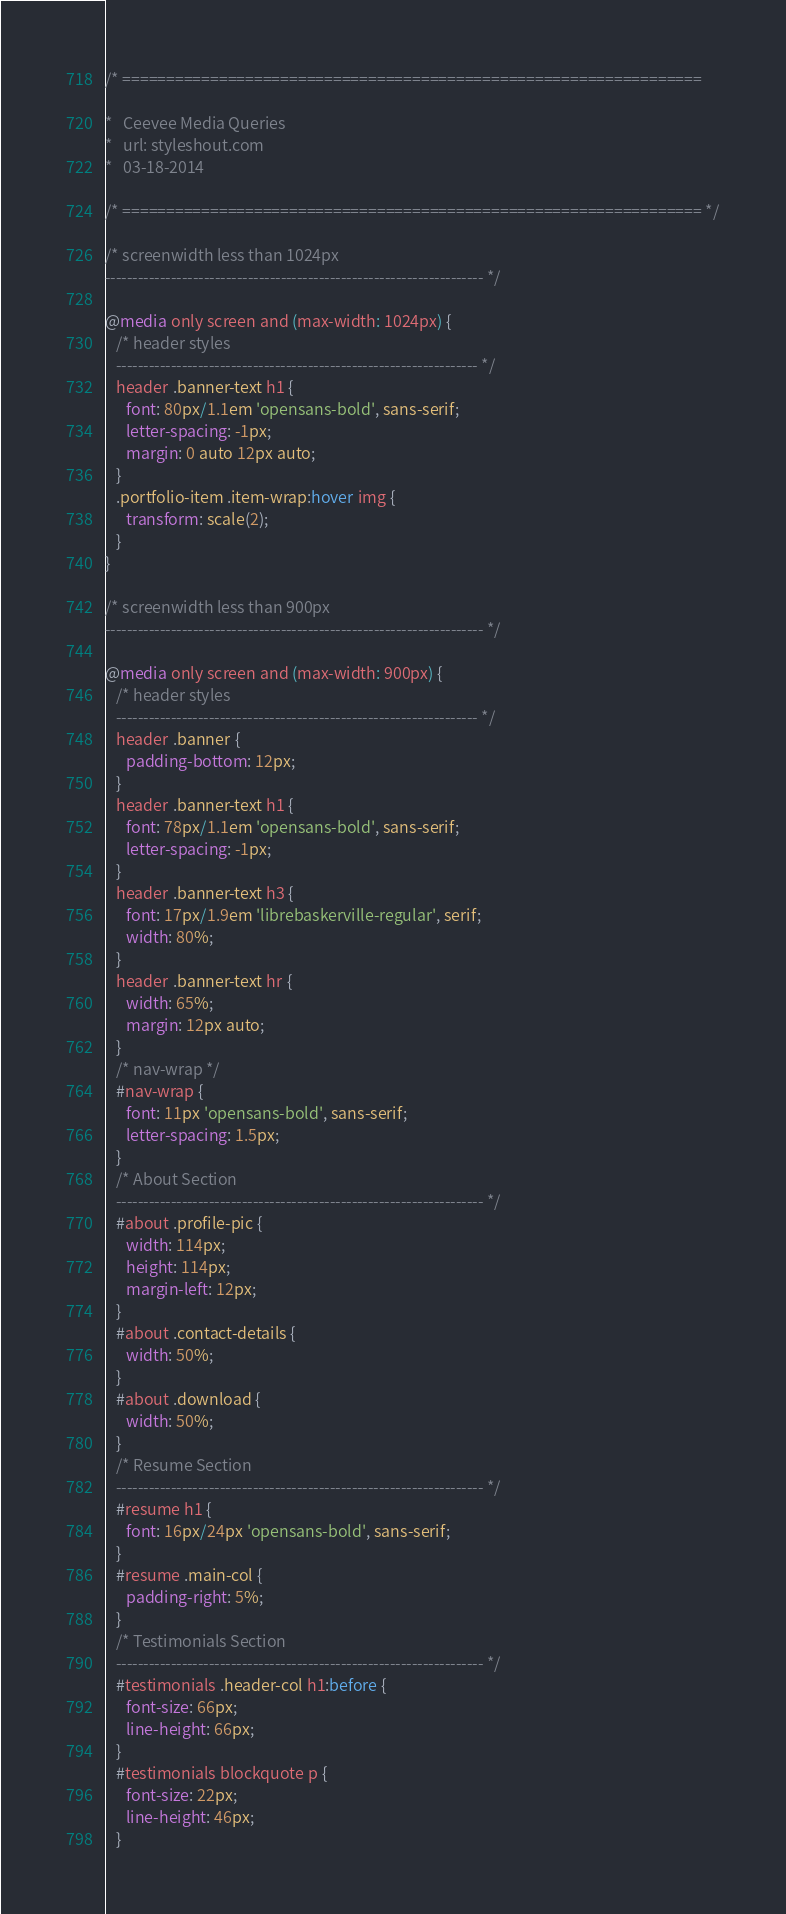Convert code to text. <code><loc_0><loc_0><loc_500><loc_500><_CSS_>/* ==================================================================

*   Ceevee Media Queries
*   url: styleshout.com
*   03-18-2014

/* ================================================================== */

/* screenwidth less than 1024px
--------------------------------------------------------------------- */

@media only screen and (max-width: 1024px) {
   /* header styles
   ------------------------------------------------------------------ */
   header .banner-text h1 {
      font: 80px/1.1em 'opensans-bold', sans-serif;
      letter-spacing: -1px;
      margin: 0 auto 12px auto;
   }
   .portfolio-item .item-wrap:hover img {
      transform: scale(2);
   }
}

/* screenwidth less than 900px
--------------------------------------------------------------------- */

@media only screen and (max-width: 900px) {
   /* header styles
   ------------------------------------------------------------------ */
   header .banner {
      padding-bottom: 12px;
   }
   header .banner-text h1 {
      font: 78px/1.1em 'opensans-bold', sans-serif;
      letter-spacing: -1px;
   }
   header .banner-text h3 {
      font: 17px/1.9em 'librebaskerville-regular', serif;
      width: 80%;
   }
   header .banner-text hr {
      width: 65%;
      margin: 12px auto;
   }
   /* nav-wrap */
   #nav-wrap {
      font: 11px 'opensans-bold', sans-serif;
      letter-spacing: 1.5px;
   }
   /* About Section
   ------------------------------------------------------------------- */
   #about .profile-pic {
      width: 114px;
      height: 114px;
      margin-left: 12px;
   }
   #about .contact-details {
      width: 50%;
   }
   #about .download {
      width: 50%;
   }
   /* Resume Section
   ------------------------------------------------------------------- */
   #resume h1 {
      font: 16px/24px 'opensans-bold', sans-serif;
   }
   #resume .main-col {
      padding-right: 5%;
   }
   /* Testimonials Section
   ------------------------------------------------------------------- */
   #testimonials .header-col h1:before {
      font-size: 66px;
      line-height: 66px;
   }
   #testimonials blockquote p {
      font-size: 22px;
      line-height: 46px;
   }</code> 